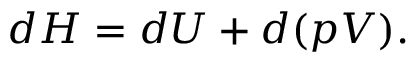<formula> <loc_0><loc_0><loc_500><loc_500>d H = d U + d ( p V ) .</formula> 